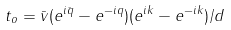Convert formula to latex. <formula><loc_0><loc_0><loc_500><loc_500>t _ { o } = \bar { v } ( e ^ { i \bar { q } } - e ^ { - i q } ) ( e ^ { i k } - e ^ { - i k } ) / d</formula> 